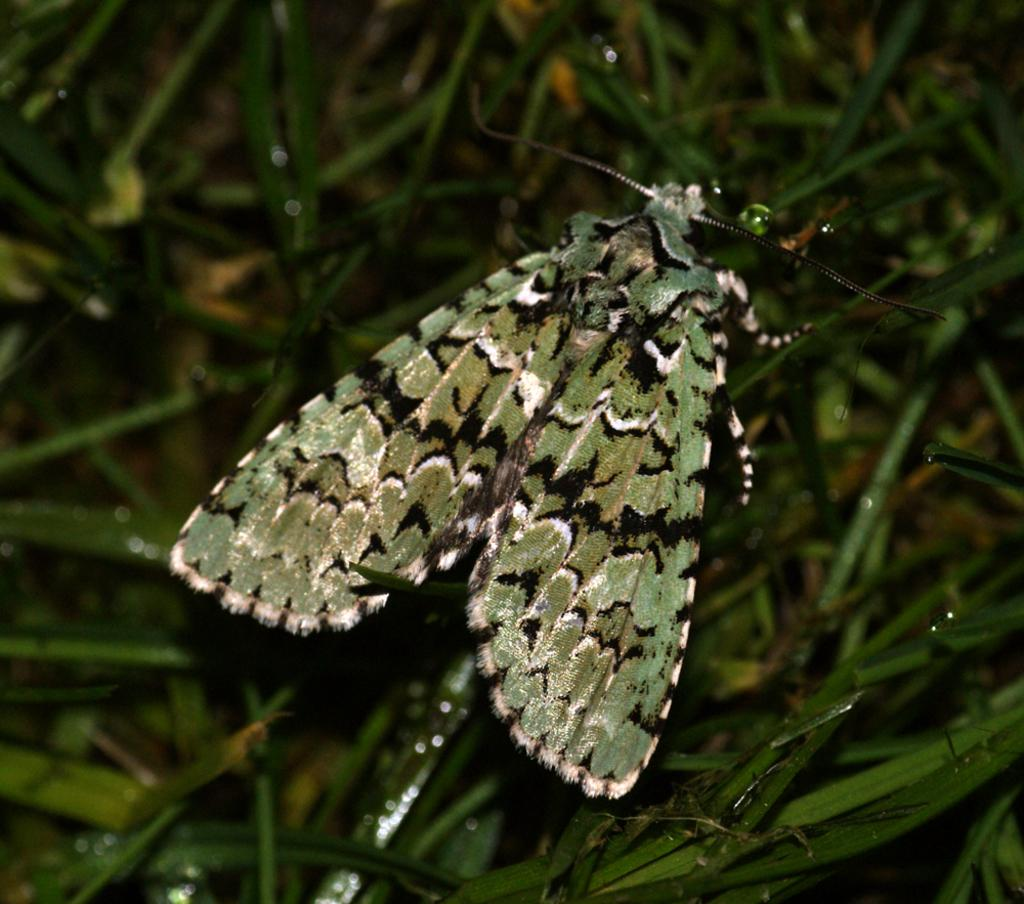What is the main subject of the image? There is a butterfly in the image. Where is the butterfly located? The butterfly is sitting on green grass. What type of zephyr can be seen interacting with the butterfly in the image? There is no zephyr present in the image, and therefore no such interaction can be observed. 